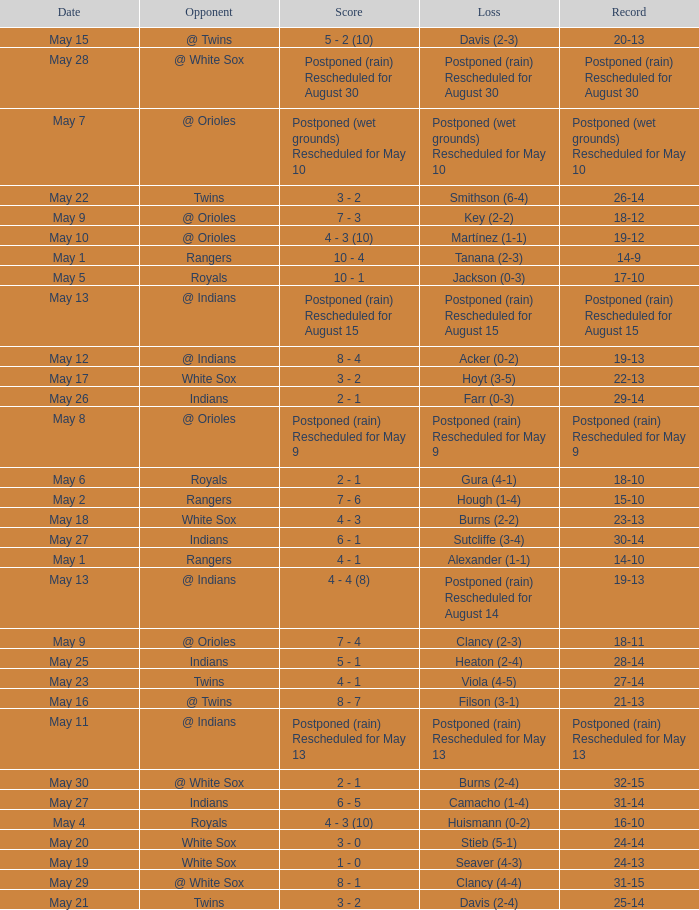What was the loss of the game when the record was 21-13? Filson (3-1). 